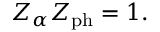Convert formula to latex. <formula><loc_0><loc_0><loc_500><loc_500>Z _ { \alpha } Z _ { p h } = 1 .</formula> 